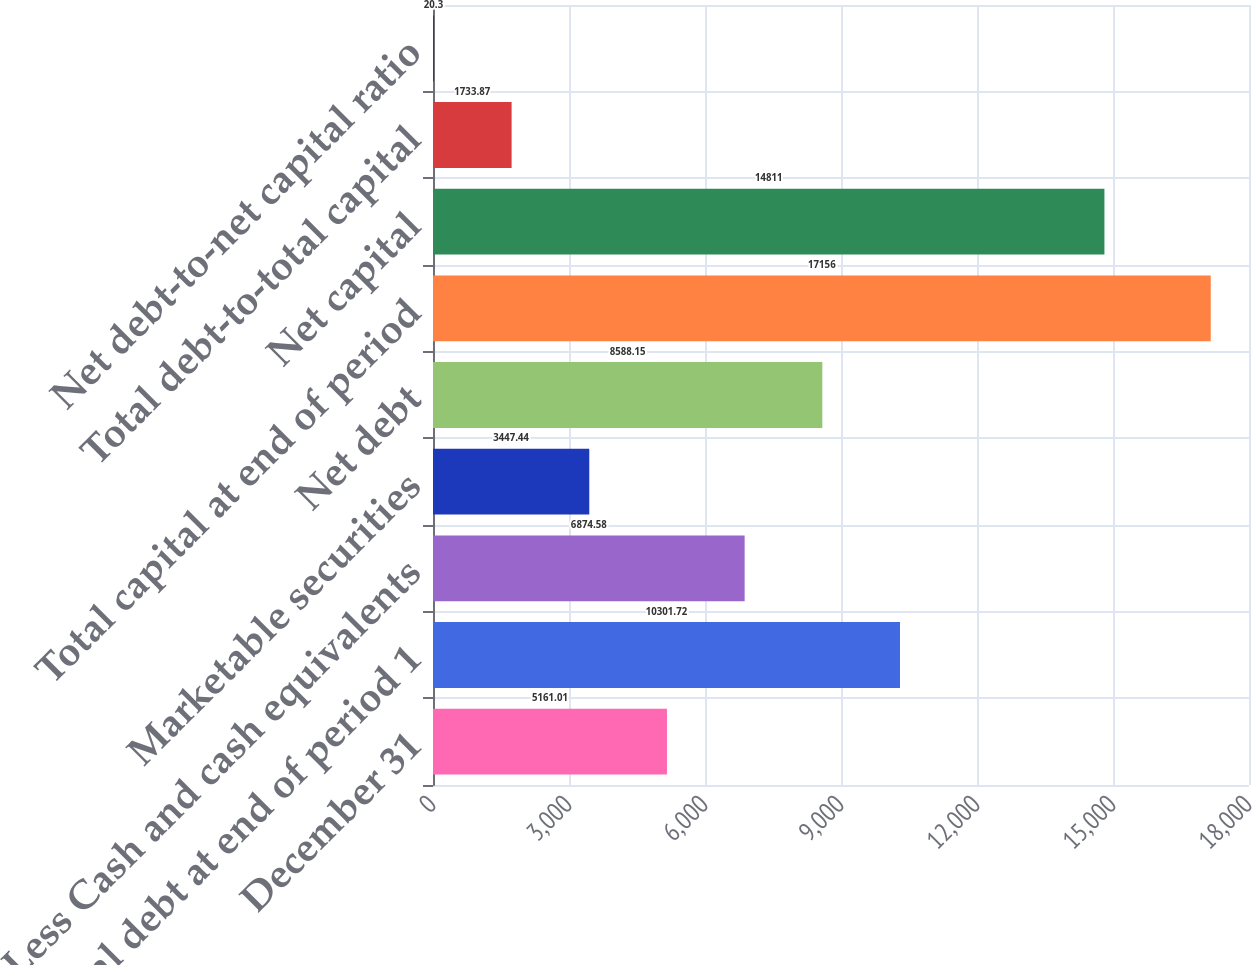<chart> <loc_0><loc_0><loc_500><loc_500><bar_chart><fcel>December 31<fcel>Total debt at end of period 1<fcel>Less Cash and cash equivalents<fcel>Marketable securities<fcel>Net debt<fcel>Total capital at end of period<fcel>Net capital<fcel>Total debt-to-total capital<fcel>Net debt-to-net capital ratio<nl><fcel>5161.01<fcel>10301.7<fcel>6874.58<fcel>3447.44<fcel>8588.15<fcel>17156<fcel>14811<fcel>1733.87<fcel>20.3<nl></chart> 